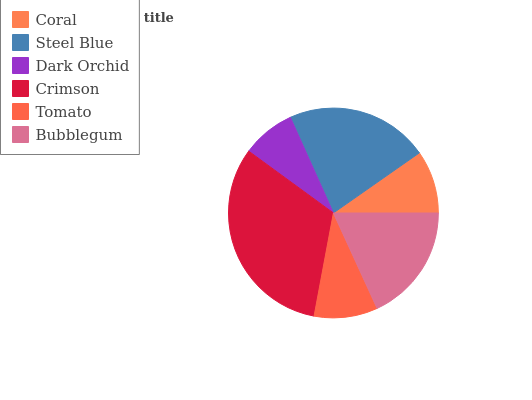Is Dark Orchid the minimum?
Answer yes or no. Yes. Is Crimson the maximum?
Answer yes or no. Yes. Is Steel Blue the minimum?
Answer yes or no. No. Is Steel Blue the maximum?
Answer yes or no. No. Is Steel Blue greater than Coral?
Answer yes or no. Yes. Is Coral less than Steel Blue?
Answer yes or no. Yes. Is Coral greater than Steel Blue?
Answer yes or no. No. Is Steel Blue less than Coral?
Answer yes or no. No. Is Bubblegum the high median?
Answer yes or no. Yes. Is Tomato the low median?
Answer yes or no. Yes. Is Coral the high median?
Answer yes or no. No. Is Steel Blue the low median?
Answer yes or no. No. 